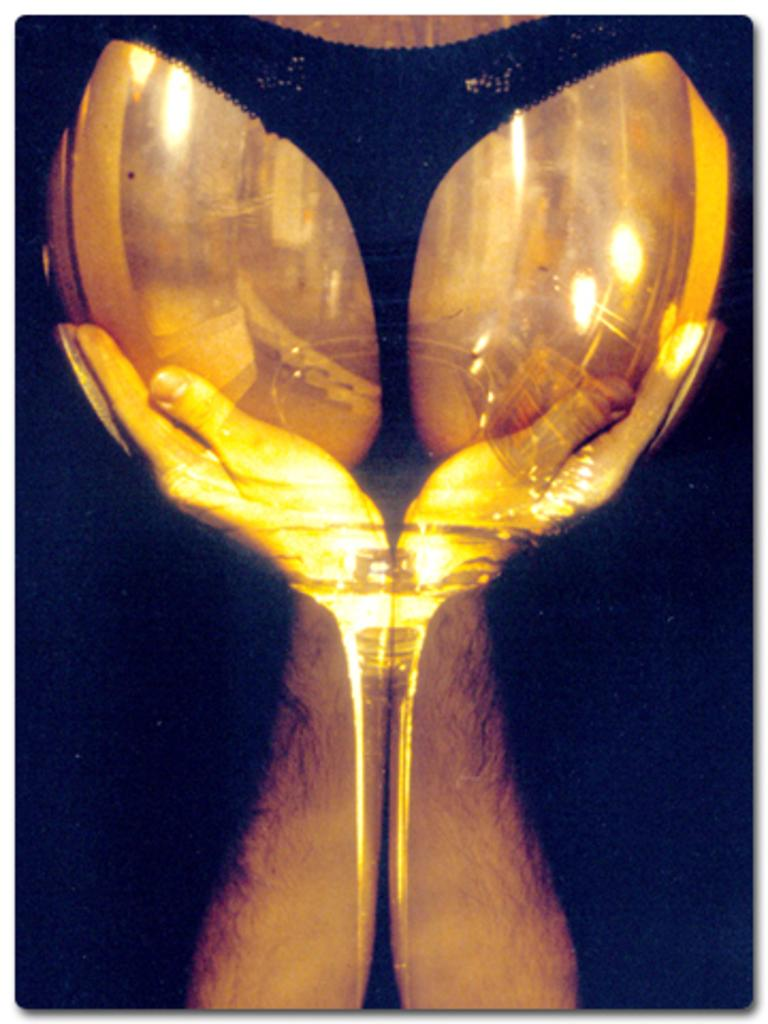What can be seen in the image involving the hands? The hands are holding objects. Can you describe the objects being held by the hands? Unfortunately, the specific objects being held by the hands are not mentioned in the provided facts. What type of grain is being held by the hands in the image? There is no mention of grain in the image or the provided facts. 